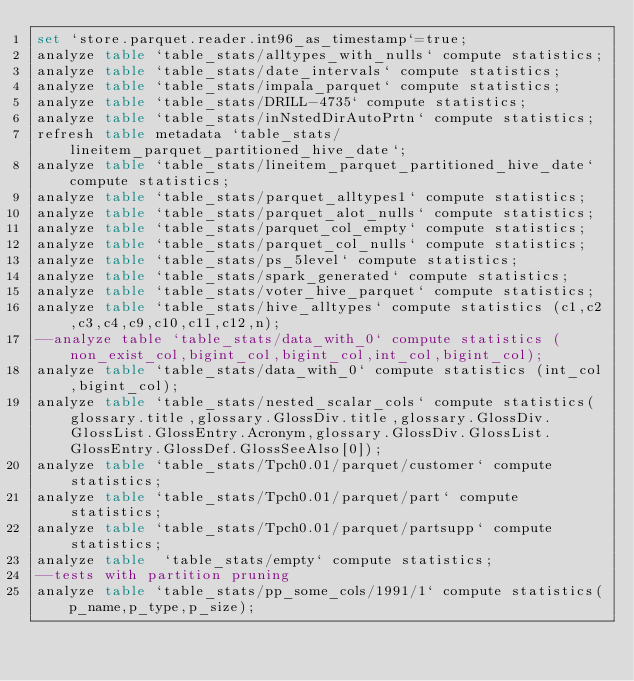Convert code to text. <code><loc_0><loc_0><loc_500><loc_500><_SQL_>set `store.parquet.reader.int96_as_timestamp`=true;
analyze table `table_stats/alltypes_with_nulls` compute statistics;
analyze table `table_stats/date_intervals` compute statistics;
analyze table `table_stats/impala_parquet` compute statistics;
analyze table `table_stats/DRILL-4735` compute statistics;
analyze table `table_stats/inNstedDirAutoPrtn` compute statistics;
refresh table metadata `table_stats/lineitem_parquet_partitioned_hive_date`;
analyze table `table_stats/lineitem_parquet_partitioned_hive_date` compute statistics;
analyze table `table_stats/parquet_alltypes1` compute statistics;
analyze table `table_stats/parquet_alot_nulls` compute statistics;
analyze table `table_stats/parquet_col_empty` compute statistics;
analyze table `table_stats/parquet_col_nulls` compute statistics;
analyze table `table_stats/ps_5level` compute statistics;
analyze table `table_stats/spark_generated` compute statistics;
analyze table `table_stats/voter_hive_parquet` compute statistics;
analyze table `table_stats/hive_alltypes` compute statistics (c1,c2,c3,c4,c9,c10,c11,c12,n);
--analyze table `table_stats/data_with_0` compute statistics (non_exist_col,bigint_col,bigint_col,int_col,bigint_col);
analyze table `table_stats/data_with_0` compute statistics (int_col,bigint_col);
analyze table `table_stats/nested_scalar_cols` compute statistics(glossary.title,glossary.GlossDiv.title,glossary.GlossDiv.GlossList.GlossEntry.Acronym,glossary.GlossDiv.GlossList.GlossEntry.GlossDef.GlossSeeAlso[0]);
analyze table `table_stats/Tpch0.01/parquet/customer` compute statistics;
analyze table `table_stats/Tpch0.01/parquet/part` compute statistics;
analyze table `table_stats/Tpch0.01/parquet/partsupp` compute statistics;
analyze table  `table_stats/empty` compute statistics;
--tests with partition pruning
analyze table `table_stats/pp_some_cols/1991/1` compute statistics(p_name,p_type,p_size);</code> 